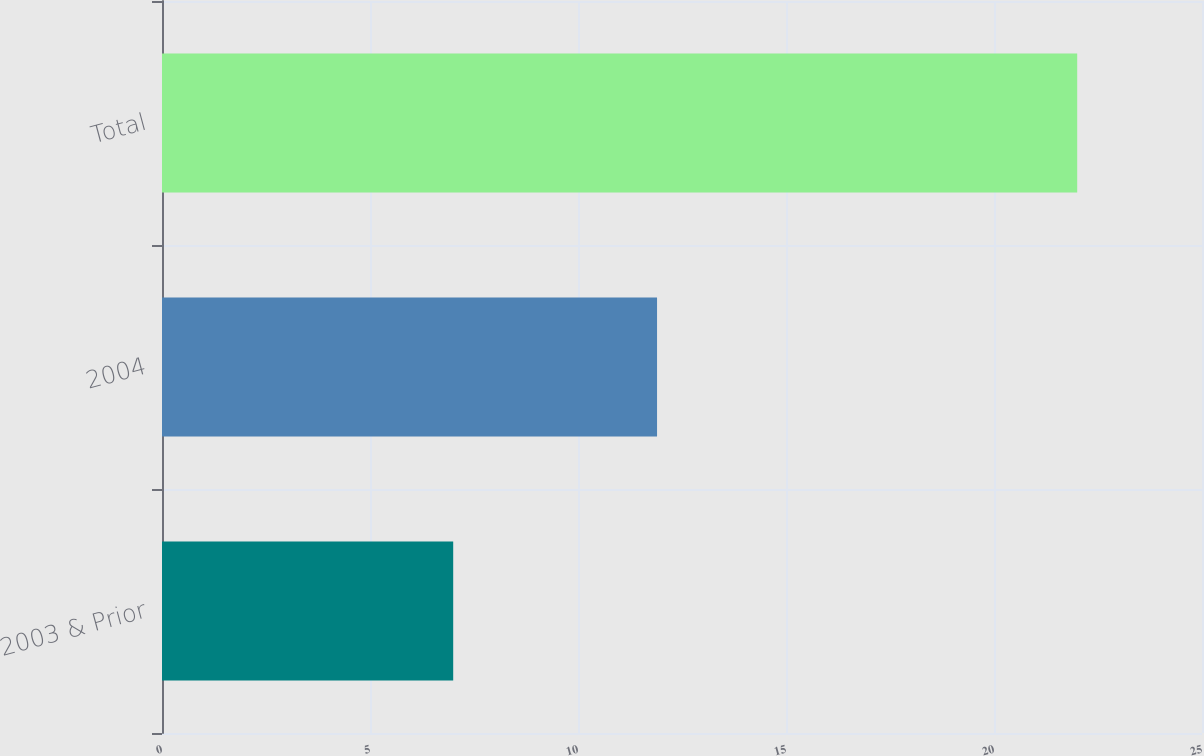Convert chart to OTSL. <chart><loc_0><loc_0><loc_500><loc_500><bar_chart><fcel>2003 & Prior<fcel>2004<fcel>Total<nl><fcel>7<fcel>11.9<fcel>22<nl></chart> 